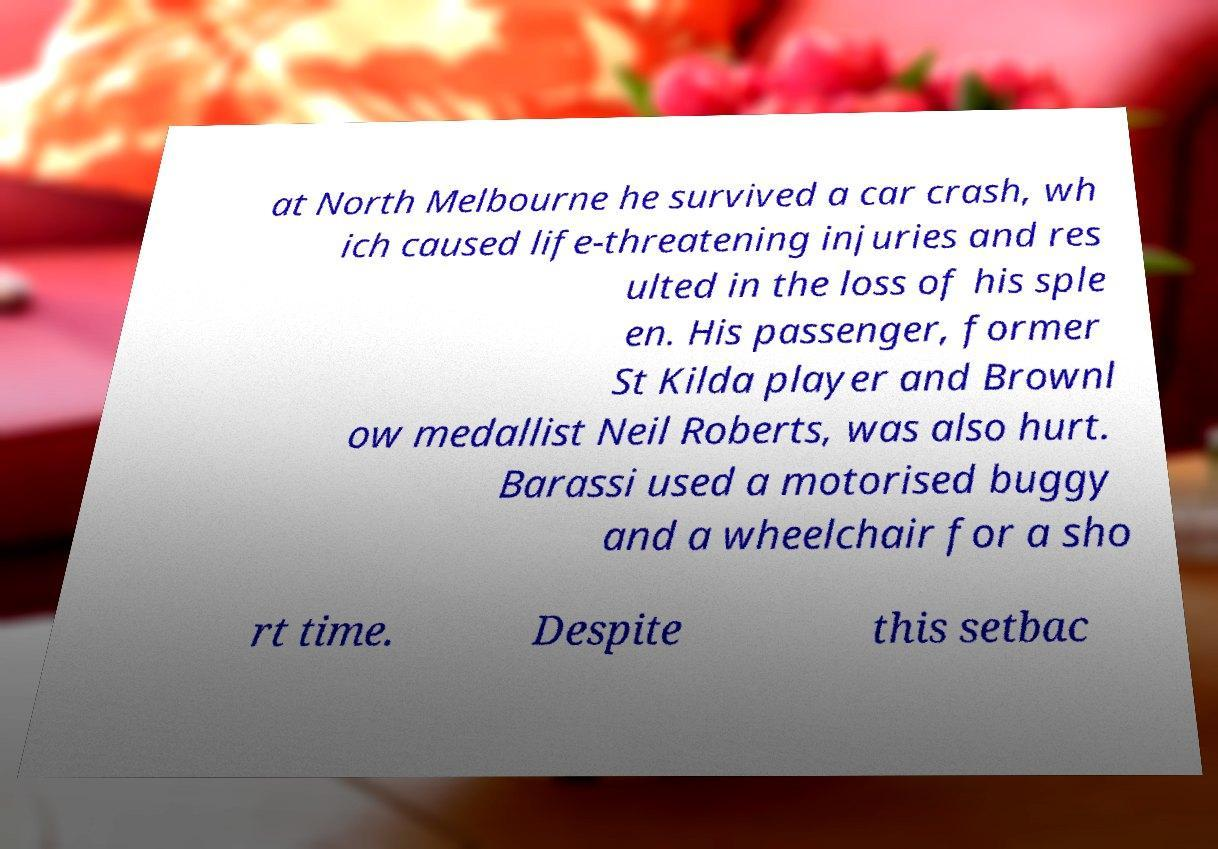I need the written content from this picture converted into text. Can you do that? at North Melbourne he survived a car crash, wh ich caused life-threatening injuries and res ulted in the loss of his sple en. His passenger, former St Kilda player and Brownl ow medallist Neil Roberts, was also hurt. Barassi used a motorised buggy and a wheelchair for a sho rt time. Despite this setbac 